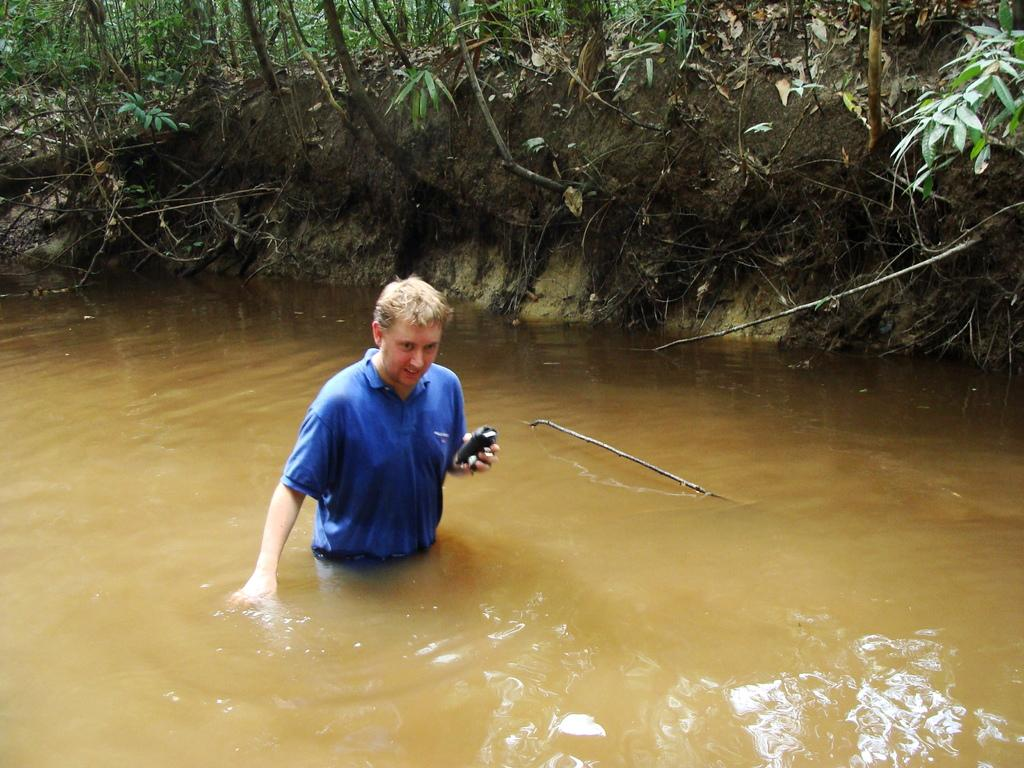Who is in the image? There is a man in the image. What is the man wearing? The man is wearing a blue T-shirt. What is the man doing in the image? The man is walking in the water. How would you describe the water in the image? The water appears to be muddy. What can be seen in the background of the image? There are plants and trees in the background of the image. What type of fruit is the man holding in the image? There is no fruit present in the image; the man is walking in the water and not holding any fruit. 